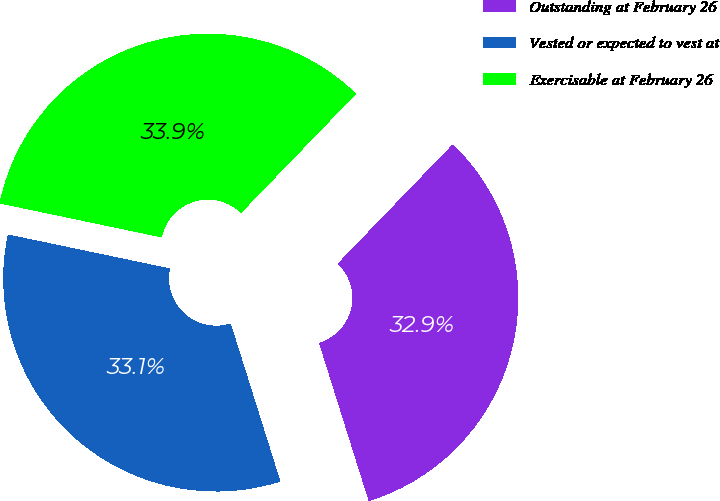Convert chart. <chart><loc_0><loc_0><loc_500><loc_500><pie_chart><fcel>Outstanding at February 26<fcel>Vested or expected to vest at<fcel>Exercisable at February 26<nl><fcel>32.94%<fcel>33.14%<fcel>33.92%<nl></chart> 